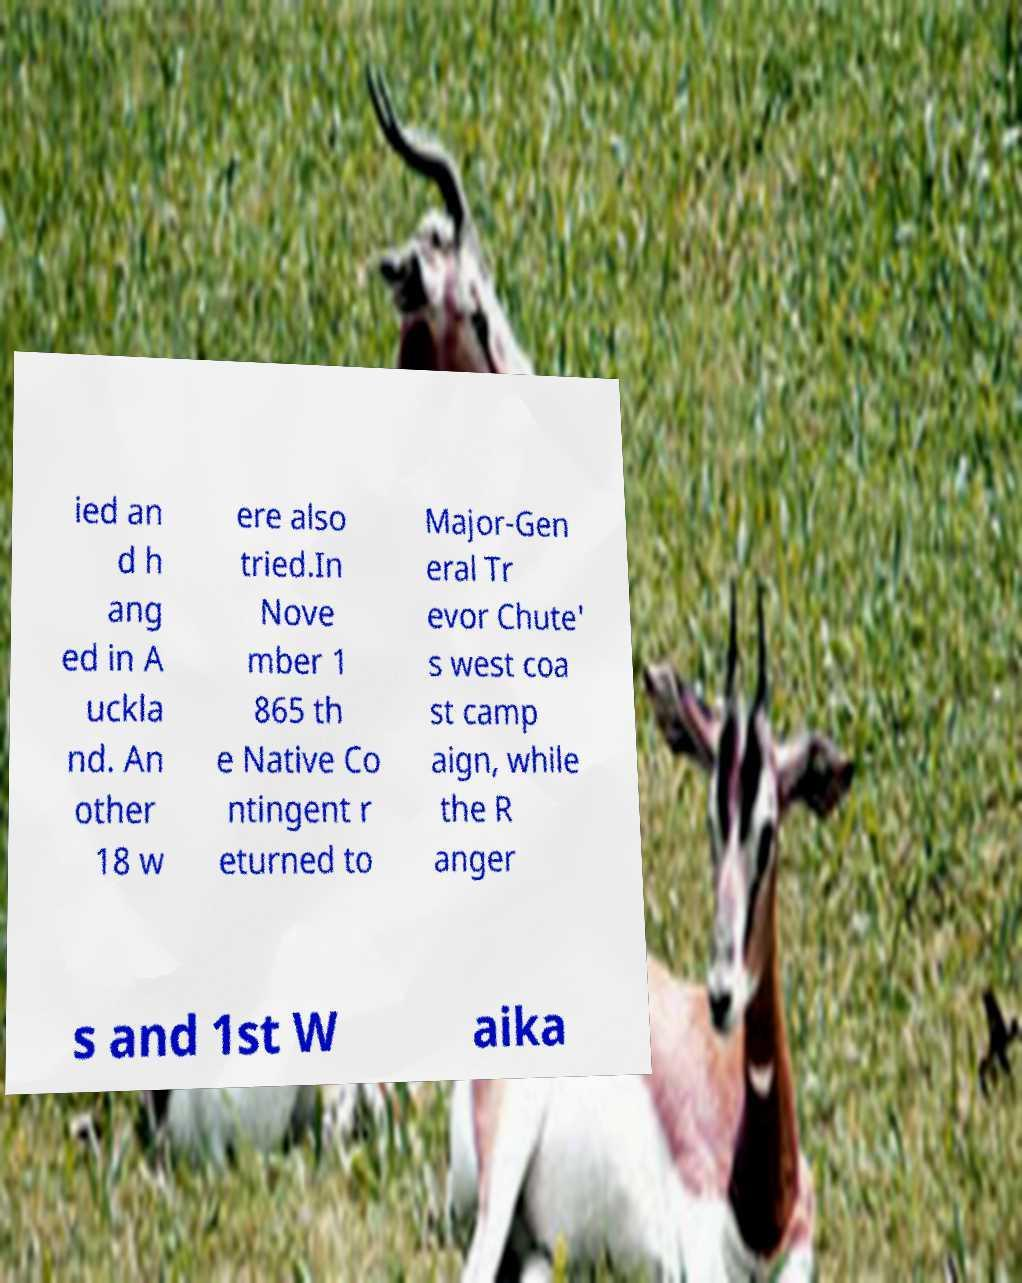Please identify and transcribe the text found in this image. ied an d h ang ed in A uckla nd. An other 18 w ere also tried.In Nove mber 1 865 th e Native Co ntingent r eturned to Major-Gen eral Tr evor Chute' s west coa st camp aign, while the R anger s and 1st W aika 